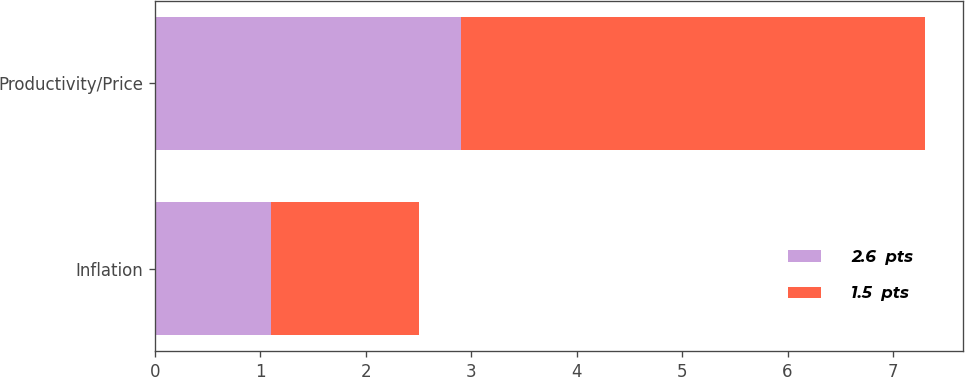<chart> <loc_0><loc_0><loc_500><loc_500><stacked_bar_chart><ecel><fcel>Inflation<fcel>Productivity/Price<nl><fcel>2.6  pts<fcel>1.1<fcel>2.9<nl><fcel>1.5  pts<fcel>1.4<fcel>4.4<nl></chart> 